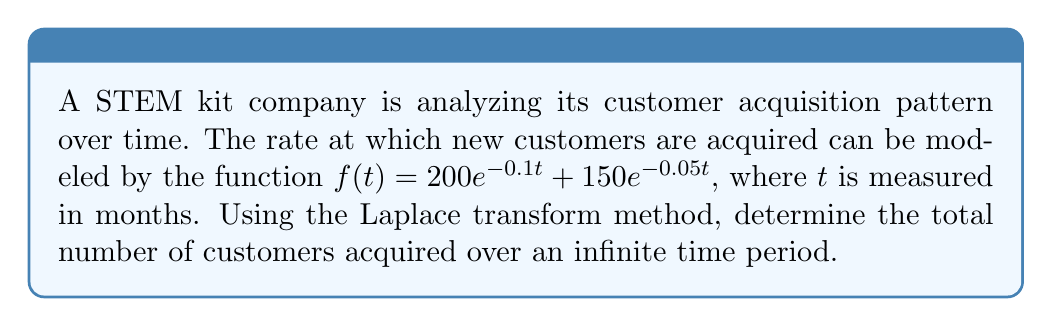Teach me how to tackle this problem. To solve this problem, we'll follow these steps:

1) First, recall that the Laplace transform of $e^{at}$ is $\frac{1}{s-a}$.

2) The Laplace transform of our function $f(t)$ is:

   $$F(s) = \mathcal{L}\{f(t)\} = \mathcal{L}\{200e^{-0.1t} + 150e^{-0.05t}\}$$
   $$= 200 \cdot \frac{1}{s+0.1} + 150 \cdot \frac{1}{s+0.05}$$

3) To find the total number of customers over an infinite time period, we need to integrate $f(t)$ from 0 to infinity. In the s-domain, this is equivalent to evaluating $F(s)$ at $s=0$:

   $$\int_0^\infty f(t) dt = \lim_{s \to 0} F(s)$$

4) Let's evaluate this limit:

   $$\lim_{s \to 0} F(s) = \lim_{s \to 0} \left(200 \cdot \frac{1}{s+0.1} + 150 \cdot \frac{1}{s+0.05}\right)$$
   $$= 200 \cdot \frac{1}{0+0.1} + 150 \cdot \frac{1}{0+0.05}$$
   $$= 200 \cdot 10 + 150 \cdot 20$$
   $$= 2000 + 3000 = 5000$$

5) Therefore, the total number of customers acquired over an infinite time period is 5000.
Answer: 5000 customers 